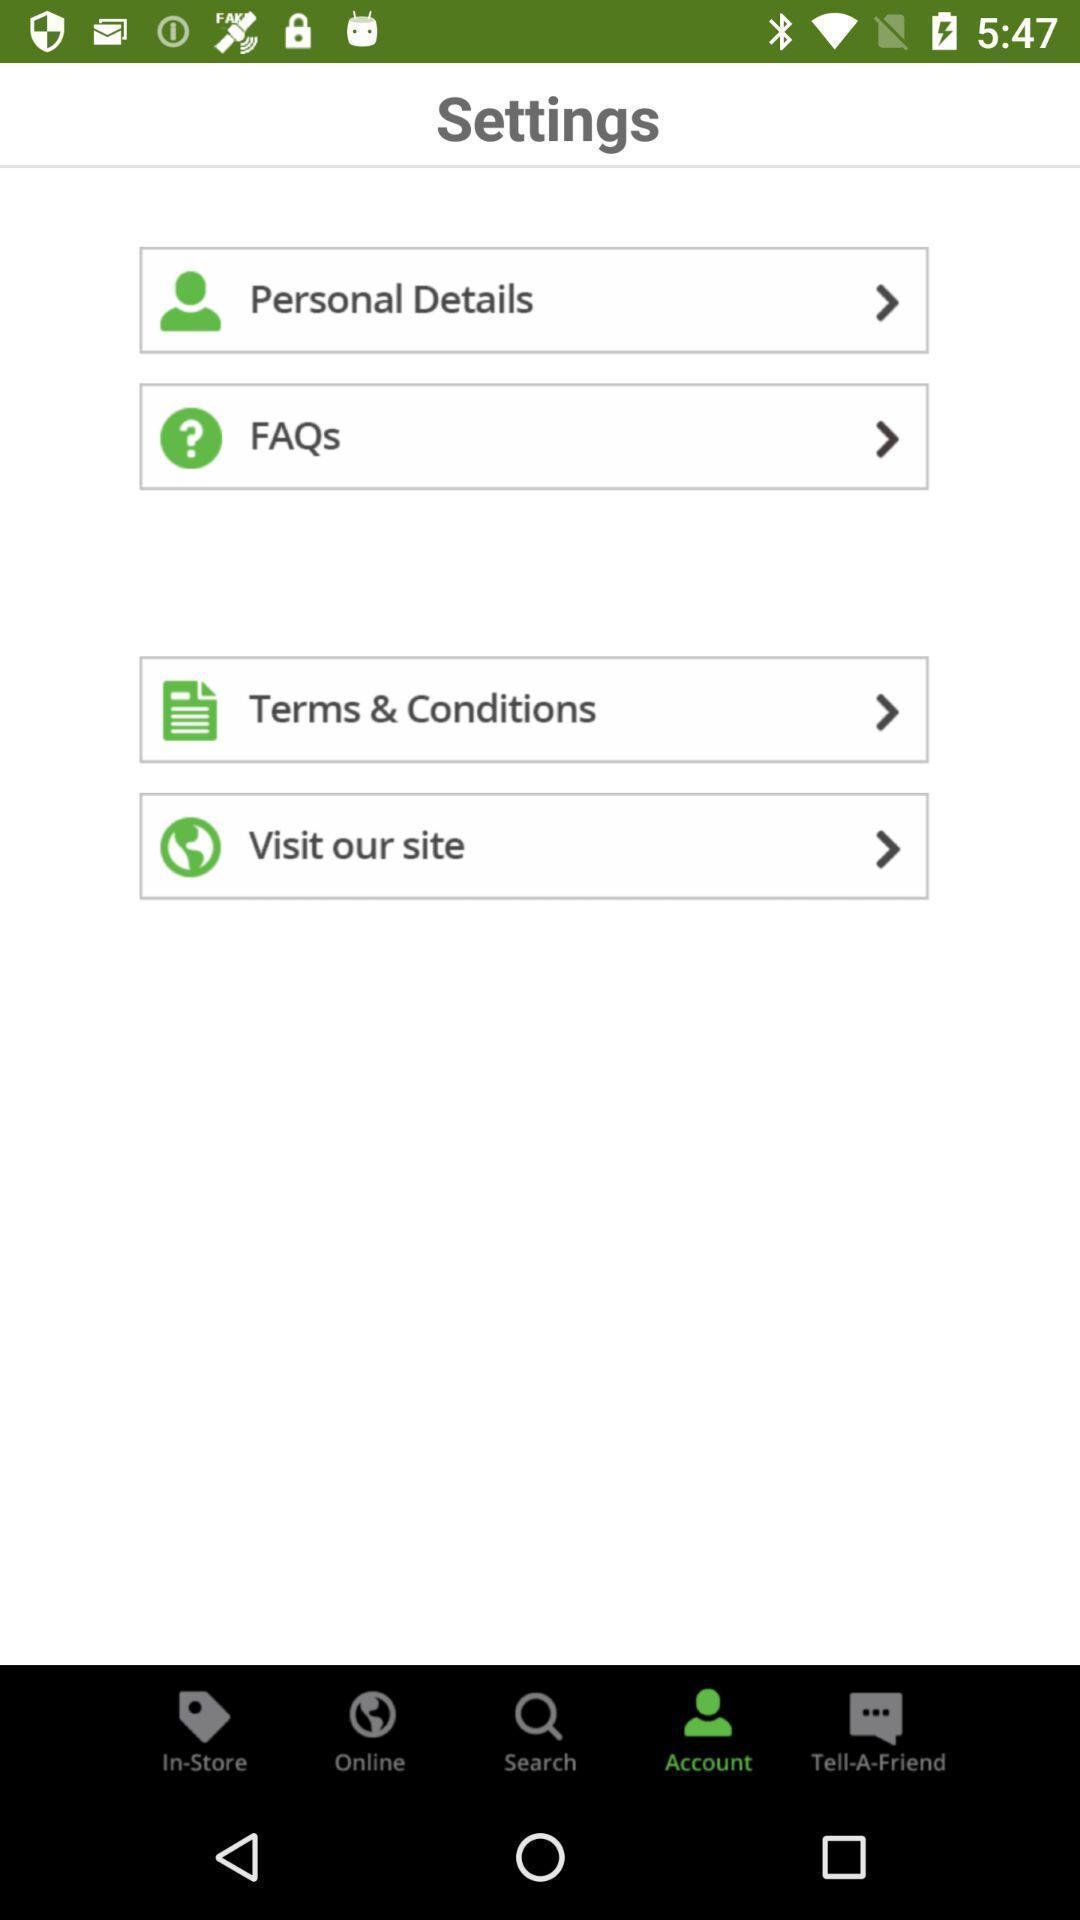Describe the content in this image. Personal settings page. 